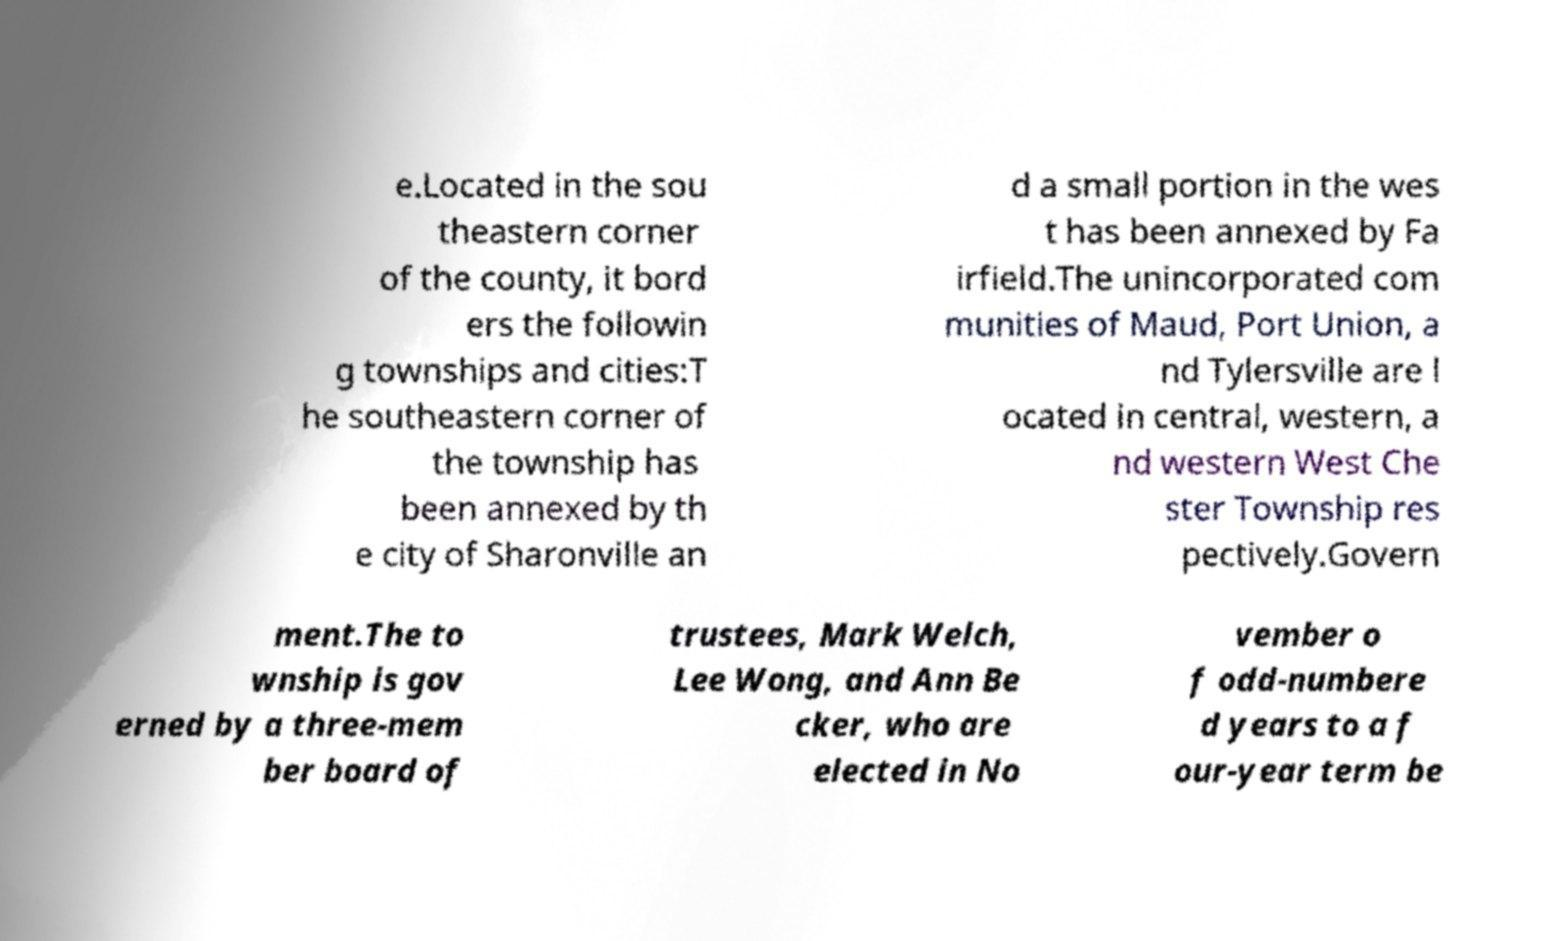Please identify and transcribe the text found in this image. e.Located in the sou theastern corner of the county, it bord ers the followin g townships and cities:T he southeastern corner of the township has been annexed by th e city of Sharonville an d a small portion in the wes t has been annexed by Fa irfield.The unincorporated com munities of Maud, Port Union, a nd Tylersville are l ocated in central, western, a nd western West Che ster Township res pectively.Govern ment.The to wnship is gov erned by a three-mem ber board of trustees, Mark Welch, Lee Wong, and Ann Be cker, who are elected in No vember o f odd-numbere d years to a f our-year term be 